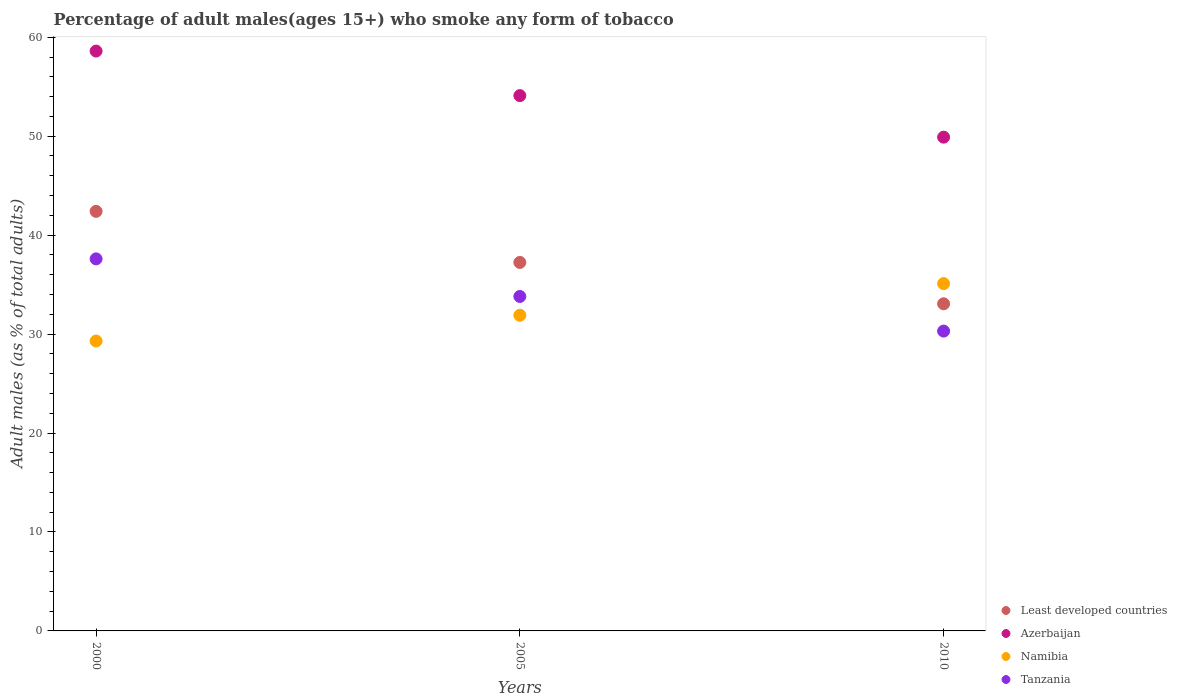Is the number of dotlines equal to the number of legend labels?
Your answer should be compact. Yes. What is the percentage of adult males who smoke in Namibia in 2010?
Provide a succinct answer. 35.1. Across all years, what is the maximum percentage of adult males who smoke in Tanzania?
Keep it short and to the point. 37.6. Across all years, what is the minimum percentage of adult males who smoke in Tanzania?
Ensure brevity in your answer.  30.3. What is the total percentage of adult males who smoke in Namibia in the graph?
Keep it short and to the point. 96.3. What is the difference between the percentage of adult males who smoke in Tanzania in 2005 and that in 2010?
Make the answer very short. 3.5. What is the difference between the percentage of adult males who smoke in Tanzania in 2005 and the percentage of adult males who smoke in Least developed countries in 2010?
Give a very brief answer. 0.74. What is the average percentage of adult males who smoke in Namibia per year?
Offer a terse response. 32.1. In the year 2005, what is the difference between the percentage of adult males who smoke in Tanzania and percentage of adult males who smoke in Least developed countries?
Offer a very short reply. -3.44. In how many years, is the percentage of adult males who smoke in Tanzania greater than 26 %?
Your answer should be very brief. 3. What is the ratio of the percentage of adult males who smoke in Tanzania in 2000 to that in 2010?
Offer a very short reply. 1.24. Is the percentage of adult males who smoke in Least developed countries in 2005 less than that in 2010?
Your response must be concise. No. What is the difference between the highest and the second highest percentage of adult males who smoke in Azerbaijan?
Your answer should be compact. 4.5. What is the difference between the highest and the lowest percentage of adult males who smoke in Least developed countries?
Offer a terse response. 9.34. Is it the case that in every year, the sum of the percentage of adult males who smoke in Least developed countries and percentage of adult males who smoke in Tanzania  is greater than the sum of percentage of adult males who smoke in Namibia and percentage of adult males who smoke in Azerbaijan?
Your answer should be very brief. No. Is it the case that in every year, the sum of the percentage of adult males who smoke in Tanzania and percentage of adult males who smoke in Least developed countries  is greater than the percentage of adult males who smoke in Azerbaijan?
Make the answer very short. Yes. Does the percentage of adult males who smoke in Azerbaijan monotonically increase over the years?
Give a very brief answer. No. Is the percentage of adult males who smoke in Namibia strictly greater than the percentage of adult males who smoke in Least developed countries over the years?
Provide a short and direct response. No. Are the values on the major ticks of Y-axis written in scientific E-notation?
Offer a very short reply. No. Does the graph contain grids?
Offer a very short reply. No. How are the legend labels stacked?
Your response must be concise. Vertical. What is the title of the graph?
Offer a terse response. Percentage of adult males(ages 15+) who smoke any form of tobacco. Does "Colombia" appear as one of the legend labels in the graph?
Keep it short and to the point. No. What is the label or title of the X-axis?
Your answer should be compact. Years. What is the label or title of the Y-axis?
Make the answer very short. Adult males (as % of total adults). What is the Adult males (as % of total adults) of Least developed countries in 2000?
Provide a succinct answer. 42.4. What is the Adult males (as % of total adults) of Azerbaijan in 2000?
Your response must be concise. 58.6. What is the Adult males (as % of total adults) in Namibia in 2000?
Provide a short and direct response. 29.3. What is the Adult males (as % of total adults) of Tanzania in 2000?
Ensure brevity in your answer.  37.6. What is the Adult males (as % of total adults) in Least developed countries in 2005?
Ensure brevity in your answer.  37.24. What is the Adult males (as % of total adults) in Azerbaijan in 2005?
Give a very brief answer. 54.1. What is the Adult males (as % of total adults) of Namibia in 2005?
Your response must be concise. 31.9. What is the Adult males (as % of total adults) of Tanzania in 2005?
Ensure brevity in your answer.  33.8. What is the Adult males (as % of total adults) of Least developed countries in 2010?
Your answer should be compact. 33.06. What is the Adult males (as % of total adults) in Azerbaijan in 2010?
Your answer should be very brief. 49.9. What is the Adult males (as % of total adults) of Namibia in 2010?
Your answer should be very brief. 35.1. What is the Adult males (as % of total adults) of Tanzania in 2010?
Offer a very short reply. 30.3. Across all years, what is the maximum Adult males (as % of total adults) of Least developed countries?
Keep it short and to the point. 42.4. Across all years, what is the maximum Adult males (as % of total adults) in Azerbaijan?
Your response must be concise. 58.6. Across all years, what is the maximum Adult males (as % of total adults) in Namibia?
Keep it short and to the point. 35.1. Across all years, what is the maximum Adult males (as % of total adults) of Tanzania?
Your response must be concise. 37.6. Across all years, what is the minimum Adult males (as % of total adults) in Least developed countries?
Give a very brief answer. 33.06. Across all years, what is the minimum Adult males (as % of total adults) of Azerbaijan?
Ensure brevity in your answer.  49.9. Across all years, what is the minimum Adult males (as % of total adults) in Namibia?
Offer a very short reply. 29.3. Across all years, what is the minimum Adult males (as % of total adults) in Tanzania?
Provide a succinct answer. 30.3. What is the total Adult males (as % of total adults) of Least developed countries in the graph?
Provide a short and direct response. 112.7. What is the total Adult males (as % of total adults) in Azerbaijan in the graph?
Provide a short and direct response. 162.6. What is the total Adult males (as % of total adults) in Namibia in the graph?
Provide a short and direct response. 96.3. What is the total Adult males (as % of total adults) of Tanzania in the graph?
Your answer should be compact. 101.7. What is the difference between the Adult males (as % of total adults) in Least developed countries in 2000 and that in 2005?
Make the answer very short. 5.16. What is the difference between the Adult males (as % of total adults) of Least developed countries in 2000 and that in 2010?
Provide a short and direct response. 9.34. What is the difference between the Adult males (as % of total adults) of Least developed countries in 2005 and that in 2010?
Your response must be concise. 4.18. What is the difference between the Adult males (as % of total adults) in Tanzania in 2005 and that in 2010?
Make the answer very short. 3.5. What is the difference between the Adult males (as % of total adults) of Least developed countries in 2000 and the Adult males (as % of total adults) of Azerbaijan in 2005?
Provide a short and direct response. -11.7. What is the difference between the Adult males (as % of total adults) in Least developed countries in 2000 and the Adult males (as % of total adults) in Namibia in 2005?
Give a very brief answer. 10.5. What is the difference between the Adult males (as % of total adults) in Least developed countries in 2000 and the Adult males (as % of total adults) in Tanzania in 2005?
Keep it short and to the point. 8.6. What is the difference between the Adult males (as % of total adults) in Azerbaijan in 2000 and the Adult males (as % of total adults) in Namibia in 2005?
Your response must be concise. 26.7. What is the difference between the Adult males (as % of total adults) of Azerbaijan in 2000 and the Adult males (as % of total adults) of Tanzania in 2005?
Make the answer very short. 24.8. What is the difference between the Adult males (as % of total adults) of Namibia in 2000 and the Adult males (as % of total adults) of Tanzania in 2005?
Offer a terse response. -4.5. What is the difference between the Adult males (as % of total adults) in Least developed countries in 2000 and the Adult males (as % of total adults) in Azerbaijan in 2010?
Keep it short and to the point. -7.5. What is the difference between the Adult males (as % of total adults) of Least developed countries in 2000 and the Adult males (as % of total adults) of Namibia in 2010?
Your answer should be compact. 7.3. What is the difference between the Adult males (as % of total adults) of Least developed countries in 2000 and the Adult males (as % of total adults) of Tanzania in 2010?
Keep it short and to the point. 12.1. What is the difference between the Adult males (as % of total adults) of Azerbaijan in 2000 and the Adult males (as % of total adults) of Namibia in 2010?
Give a very brief answer. 23.5. What is the difference between the Adult males (as % of total adults) in Azerbaijan in 2000 and the Adult males (as % of total adults) in Tanzania in 2010?
Your response must be concise. 28.3. What is the difference between the Adult males (as % of total adults) in Least developed countries in 2005 and the Adult males (as % of total adults) in Azerbaijan in 2010?
Keep it short and to the point. -12.66. What is the difference between the Adult males (as % of total adults) in Least developed countries in 2005 and the Adult males (as % of total adults) in Namibia in 2010?
Your response must be concise. 2.14. What is the difference between the Adult males (as % of total adults) in Least developed countries in 2005 and the Adult males (as % of total adults) in Tanzania in 2010?
Your answer should be very brief. 6.94. What is the difference between the Adult males (as % of total adults) of Azerbaijan in 2005 and the Adult males (as % of total adults) of Tanzania in 2010?
Your response must be concise. 23.8. What is the average Adult males (as % of total adults) in Least developed countries per year?
Your answer should be compact. 37.57. What is the average Adult males (as % of total adults) in Azerbaijan per year?
Give a very brief answer. 54.2. What is the average Adult males (as % of total adults) of Namibia per year?
Provide a succinct answer. 32.1. What is the average Adult males (as % of total adults) of Tanzania per year?
Keep it short and to the point. 33.9. In the year 2000, what is the difference between the Adult males (as % of total adults) in Least developed countries and Adult males (as % of total adults) in Azerbaijan?
Your response must be concise. -16.2. In the year 2000, what is the difference between the Adult males (as % of total adults) of Least developed countries and Adult males (as % of total adults) of Namibia?
Your response must be concise. 13.1. In the year 2000, what is the difference between the Adult males (as % of total adults) of Least developed countries and Adult males (as % of total adults) of Tanzania?
Provide a short and direct response. 4.8. In the year 2000, what is the difference between the Adult males (as % of total adults) of Azerbaijan and Adult males (as % of total adults) of Namibia?
Provide a succinct answer. 29.3. In the year 2000, what is the difference between the Adult males (as % of total adults) of Azerbaijan and Adult males (as % of total adults) of Tanzania?
Your answer should be very brief. 21. In the year 2005, what is the difference between the Adult males (as % of total adults) of Least developed countries and Adult males (as % of total adults) of Azerbaijan?
Your response must be concise. -16.86. In the year 2005, what is the difference between the Adult males (as % of total adults) in Least developed countries and Adult males (as % of total adults) in Namibia?
Keep it short and to the point. 5.34. In the year 2005, what is the difference between the Adult males (as % of total adults) of Least developed countries and Adult males (as % of total adults) of Tanzania?
Your answer should be compact. 3.44. In the year 2005, what is the difference between the Adult males (as % of total adults) of Azerbaijan and Adult males (as % of total adults) of Namibia?
Keep it short and to the point. 22.2. In the year 2005, what is the difference between the Adult males (as % of total adults) in Azerbaijan and Adult males (as % of total adults) in Tanzania?
Your answer should be compact. 20.3. In the year 2010, what is the difference between the Adult males (as % of total adults) in Least developed countries and Adult males (as % of total adults) in Azerbaijan?
Keep it short and to the point. -16.84. In the year 2010, what is the difference between the Adult males (as % of total adults) in Least developed countries and Adult males (as % of total adults) in Namibia?
Your answer should be very brief. -2.04. In the year 2010, what is the difference between the Adult males (as % of total adults) of Least developed countries and Adult males (as % of total adults) of Tanzania?
Keep it short and to the point. 2.76. In the year 2010, what is the difference between the Adult males (as % of total adults) of Azerbaijan and Adult males (as % of total adults) of Namibia?
Offer a very short reply. 14.8. In the year 2010, what is the difference between the Adult males (as % of total adults) of Azerbaijan and Adult males (as % of total adults) of Tanzania?
Keep it short and to the point. 19.6. What is the ratio of the Adult males (as % of total adults) in Least developed countries in 2000 to that in 2005?
Give a very brief answer. 1.14. What is the ratio of the Adult males (as % of total adults) of Azerbaijan in 2000 to that in 2005?
Your answer should be very brief. 1.08. What is the ratio of the Adult males (as % of total adults) in Namibia in 2000 to that in 2005?
Your answer should be very brief. 0.92. What is the ratio of the Adult males (as % of total adults) in Tanzania in 2000 to that in 2005?
Your answer should be very brief. 1.11. What is the ratio of the Adult males (as % of total adults) of Least developed countries in 2000 to that in 2010?
Offer a terse response. 1.28. What is the ratio of the Adult males (as % of total adults) of Azerbaijan in 2000 to that in 2010?
Your answer should be very brief. 1.17. What is the ratio of the Adult males (as % of total adults) in Namibia in 2000 to that in 2010?
Offer a very short reply. 0.83. What is the ratio of the Adult males (as % of total adults) in Tanzania in 2000 to that in 2010?
Provide a short and direct response. 1.24. What is the ratio of the Adult males (as % of total adults) in Least developed countries in 2005 to that in 2010?
Offer a very short reply. 1.13. What is the ratio of the Adult males (as % of total adults) in Azerbaijan in 2005 to that in 2010?
Offer a very short reply. 1.08. What is the ratio of the Adult males (as % of total adults) of Namibia in 2005 to that in 2010?
Offer a very short reply. 0.91. What is the ratio of the Adult males (as % of total adults) of Tanzania in 2005 to that in 2010?
Keep it short and to the point. 1.12. What is the difference between the highest and the second highest Adult males (as % of total adults) in Least developed countries?
Offer a very short reply. 5.16. What is the difference between the highest and the second highest Adult males (as % of total adults) in Tanzania?
Ensure brevity in your answer.  3.8. What is the difference between the highest and the lowest Adult males (as % of total adults) of Least developed countries?
Offer a very short reply. 9.34. What is the difference between the highest and the lowest Adult males (as % of total adults) in Azerbaijan?
Ensure brevity in your answer.  8.7. What is the difference between the highest and the lowest Adult males (as % of total adults) of Namibia?
Make the answer very short. 5.8. What is the difference between the highest and the lowest Adult males (as % of total adults) of Tanzania?
Make the answer very short. 7.3. 